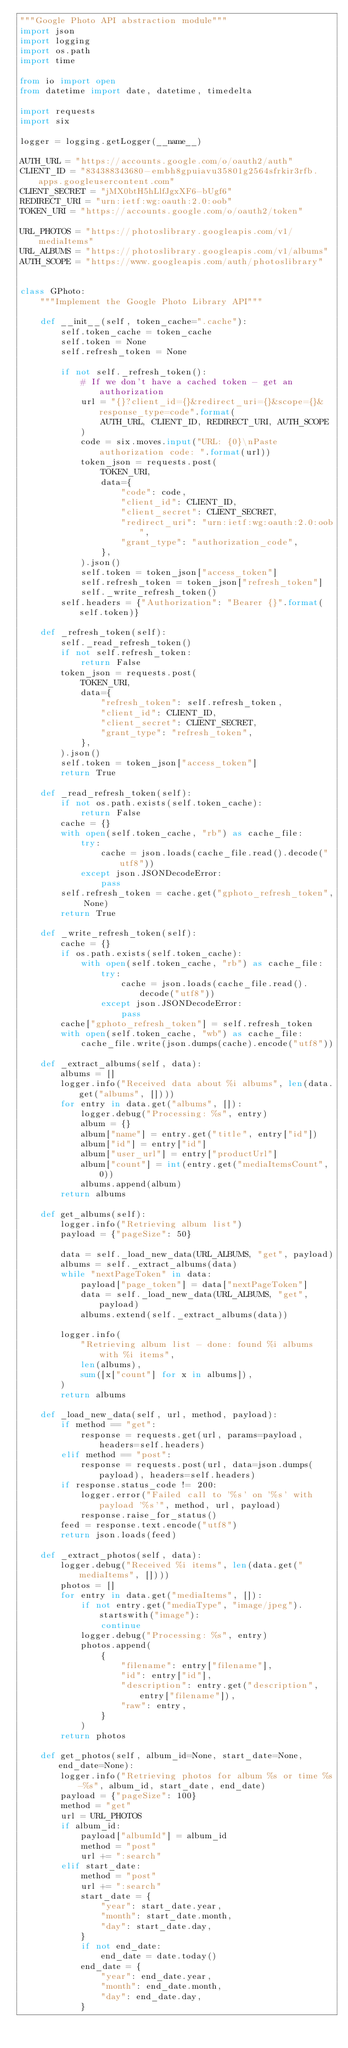Convert code to text. <code><loc_0><loc_0><loc_500><loc_500><_Python_>"""Google Photo API abstraction module"""
import json
import logging
import os.path
import time

from io import open
from datetime import date, datetime, timedelta

import requests
import six

logger = logging.getLogger(__name__)

AUTH_URL = "https://accounts.google.com/o/oauth2/auth"
CLIENT_ID = "834388343680-embh8gpuiavu35801g2564sfrkir3rfb.apps.googleusercontent.com"
CLIENT_SECRET = "jMX0btH5hLlfJgxXF6-bUgf6"
REDIRECT_URI = "urn:ietf:wg:oauth:2.0:oob"
TOKEN_URI = "https://accounts.google.com/o/oauth2/token"

URL_PHOTOS = "https://photoslibrary.googleapis.com/v1/mediaItems"
URL_ALBUMS = "https://photoslibrary.googleapis.com/v1/albums"
AUTH_SCOPE = "https://www.googleapis.com/auth/photoslibrary"


class GPhoto:
    """Implement the Google Photo Library API"""

    def __init__(self, token_cache=".cache"):
        self.token_cache = token_cache
        self.token = None
        self.refresh_token = None

        if not self._refresh_token():
            # If we don't have a cached token - get an authorization
            url = "{}?client_id={}&redirect_uri={}&scope={}&response_type=code".format(
                AUTH_URL, CLIENT_ID, REDIRECT_URI, AUTH_SCOPE
            )
            code = six.moves.input("URL: {0}\nPaste authorization code: ".format(url))
            token_json = requests.post(
                TOKEN_URI,
                data={
                    "code": code,
                    "client_id": CLIENT_ID,
                    "client_secret": CLIENT_SECRET,
                    "redirect_uri": "urn:ietf:wg:oauth:2.0:oob",
                    "grant_type": "authorization_code",
                },
            ).json()
            self.token = token_json["access_token"]
            self.refresh_token = token_json["refresh_token"]
            self._write_refresh_token()
        self.headers = {"Authorization": "Bearer {}".format(self.token)}

    def _refresh_token(self):
        self._read_refresh_token()
        if not self.refresh_token:
            return False
        token_json = requests.post(
            TOKEN_URI,
            data={
                "refresh_token": self.refresh_token,
                "client_id": CLIENT_ID,
                "client_secret": CLIENT_SECRET,
                "grant_type": "refresh_token",
            },
        ).json()
        self.token = token_json["access_token"]
        return True

    def _read_refresh_token(self):
        if not os.path.exists(self.token_cache):
            return False
        cache = {}
        with open(self.token_cache, "rb") as cache_file:
            try:
                cache = json.loads(cache_file.read().decode("utf8"))
            except json.JSONDecodeError:
                pass
        self.refresh_token = cache.get("gphoto_refresh_token", None)
        return True

    def _write_refresh_token(self):
        cache = {}
        if os.path.exists(self.token_cache):
            with open(self.token_cache, "rb") as cache_file:
                try:
                    cache = json.loads(cache_file.read().decode("utf8"))
                except json.JSONDecodeError:
                    pass
        cache["gphoto_refresh_token"] = self.refresh_token
        with open(self.token_cache, "wb") as cache_file:
            cache_file.write(json.dumps(cache).encode("utf8"))

    def _extract_albums(self, data):
        albums = []
        logger.info("Received data about %i albums", len(data.get("albums", [])))
        for entry in data.get("albums", []):
            logger.debug("Processing: %s", entry)
            album = {}
            album["name"] = entry.get("title", entry["id"])
            album["id"] = entry["id"]
            album["user_url"] = entry["productUrl"]
            album["count"] = int(entry.get("mediaItemsCount", 0))
            albums.append(album)
        return albums

    def get_albums(self):
        logger.info("Retrieving album list")
        payload = {"pageSize": 50}

        data = self._load_new_data(URL_ALBUMS, "get", payload)
        albums = self._extract_albums(data)
        while "nextPageToken" in data:
            payload["page_token"] = data["nextPageToken"]
            data = self._load_new_data(URL_ALBUMS, "get", payload)
            albums.extend(self._extract_albums(data))

        logger.info(
            "Retrieving album list - done: found %i albums with %i items",
            len(albums),
            sum([x["count"] for x in albums]),
        )
        return albums

    def _load_new_data(self, url, method, payload):
        if method == "get":
            response = requests.get(url, params=payload, headers=self.headers)
        elif method == "post":
            response = requests.post(url, data=json.dumps(payload), headers=self.headers)
        if response.status_code != 200:
            logger.error("Failed call to '%s' on '%s' with payload '%s'", method, url, payload)
            response.raise_for_status()
        feed = response.text.encode("utf8")
        return json.loads(feed)

    def _extract_photos(self, data):
        logger.debug("Received %i items", len(data.get("mediaItems", [])))
        photos = []
        for entry in data.get("mediaItems", []):
            if not entry.get("mediaType", "image/jpeg").startswith("image"):
                continue
            logger.debug("Processing: %s", entry)
            photos.append(
                {
                    "filename": entry["filename"],
                    "id": entry["id"],
                    "description": entry.get("description", entry["filename"]),
                    "raw": entry,
                }
            )
        return photos

    def get_photos(self, album_id=None, start_date=None, end_date=None):
        logger.info("Retrieving photos for album %s or time %s-%s", album_id, start_date, end_date)
        payload = {"pageSize": 100}
        method = "get"
        url = URL_PHOTOS
        if album_id:
            payload["albumId"] = album_id
            method = "post"
            url += ":search"
        elif start_date:
            method = "post"
            url += ":search"
            start_date = {
                "year": start_date.year,
                "month": start_date.month,
                "day": start_date.day,
            }
            if not end_date:
                end_date = date.today()
            end_date = {
                "year": end_date.year,
                "month": end_date.month,
                "day": end_date.day,
            }</code> 